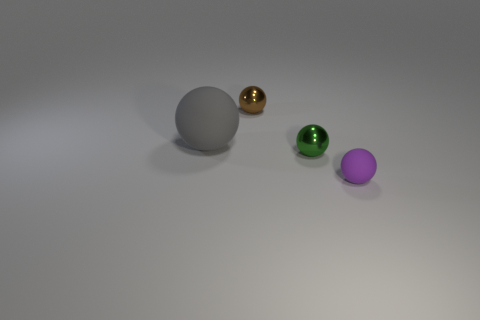Add 1 green objects. How many objects exist? 5 Subtract all purple matte spheres. How many spheres are left? 3 Subtract all big brown blocks. Subtract all purple things. How many objects are left? 3 Add 1 small rubber balls. How many small rubber balls are left? 2 Add 2 green metal balls. How many green metal balls exist? 3 Subtract all green balls. How many balls are left? 3 Subtract 0 blue cylinders. How many objects are left? 4 Subtract 2 spheres. How many spheres are left? 2 Subtract all red balls. Subtract all green cubes. How many balls are left? 4 Subtract all purple cylinders. How many purple spheres are left? 1 